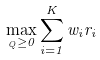<formula> <loc_0><loc_0><loc_500><loc_500>\underset { _ { Q } \geq 0 } { \max } \sum _ { i = 1 } ^ { K } w _ { i } r _ { i }</formula> 